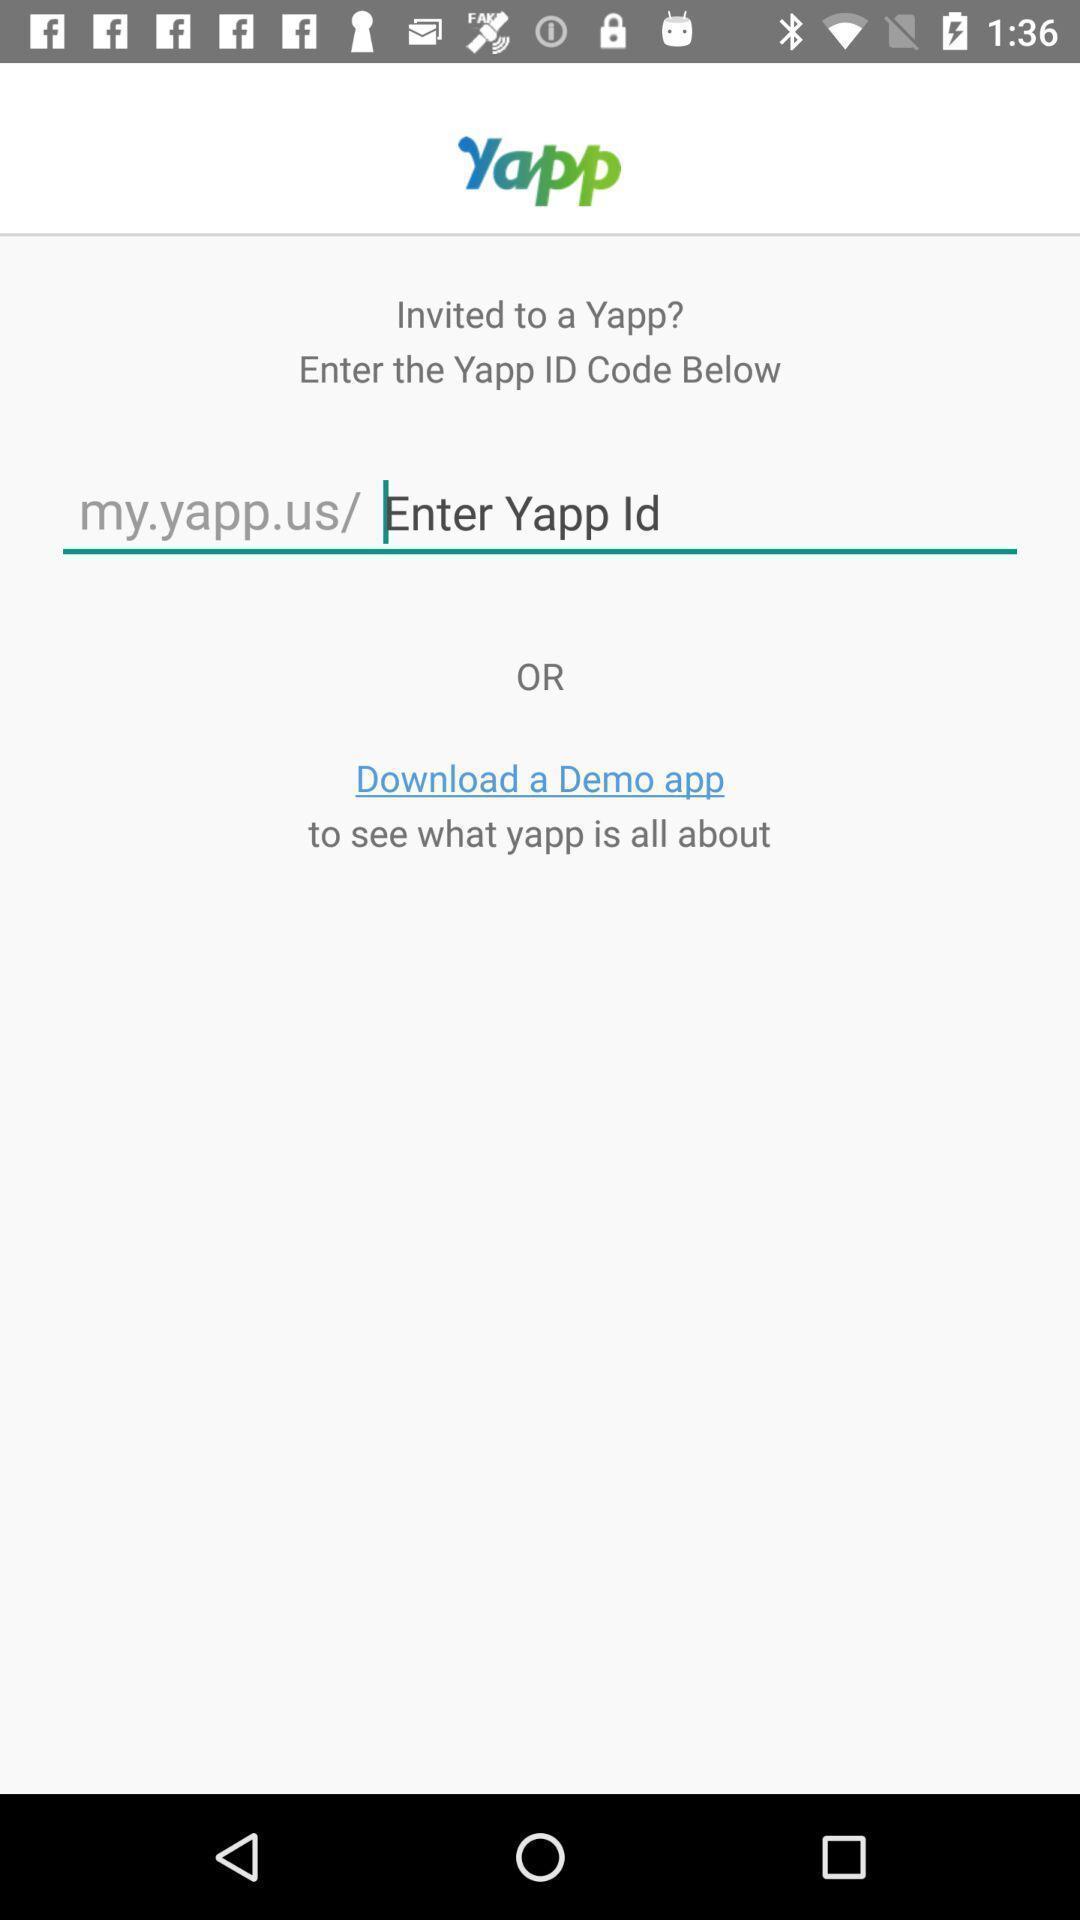Explain the elements present in this screenshot. Screen showing to enter app id. 